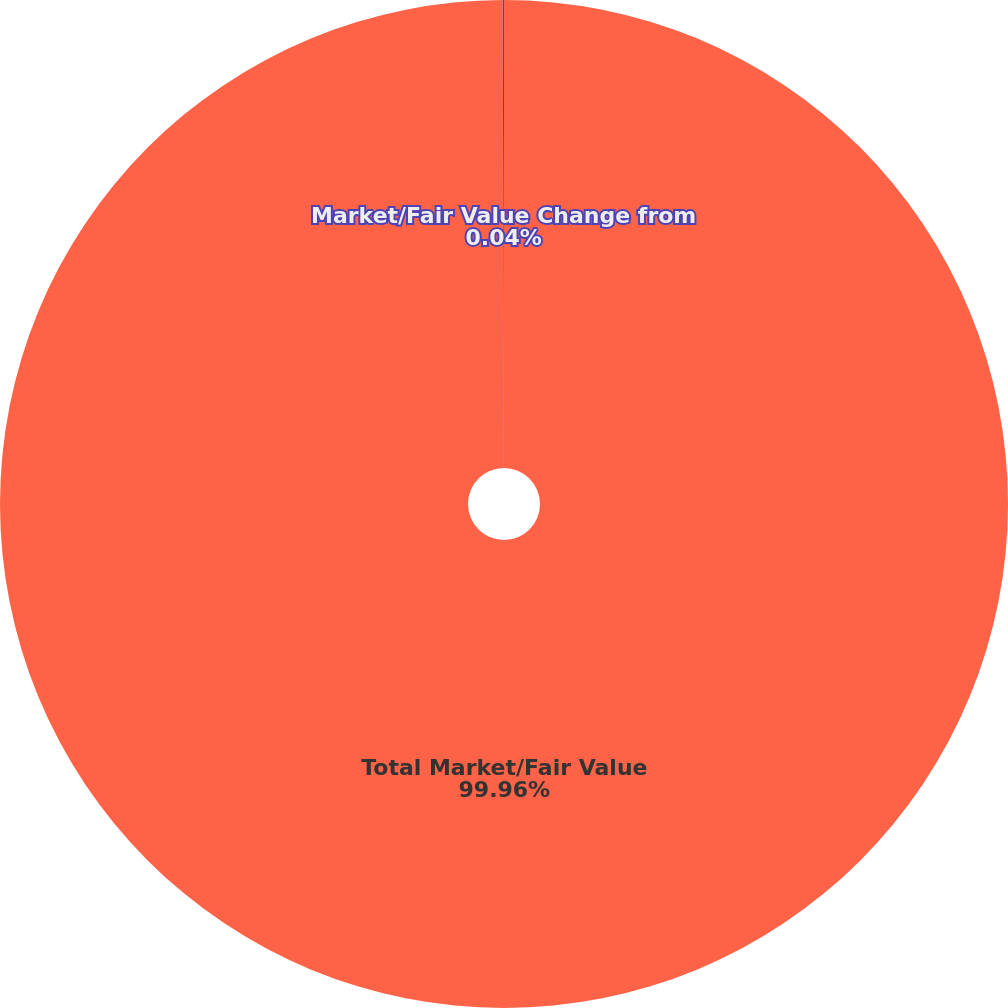Convert chart. <chart><loc_0><loc_0><loc_500><loc_500><pie_chart><fcel>Total Market/Fair Value<fcel>Market/Fair Value Change from<nl><fcel>99.96%<fcel>0.04%<nl></chart> 